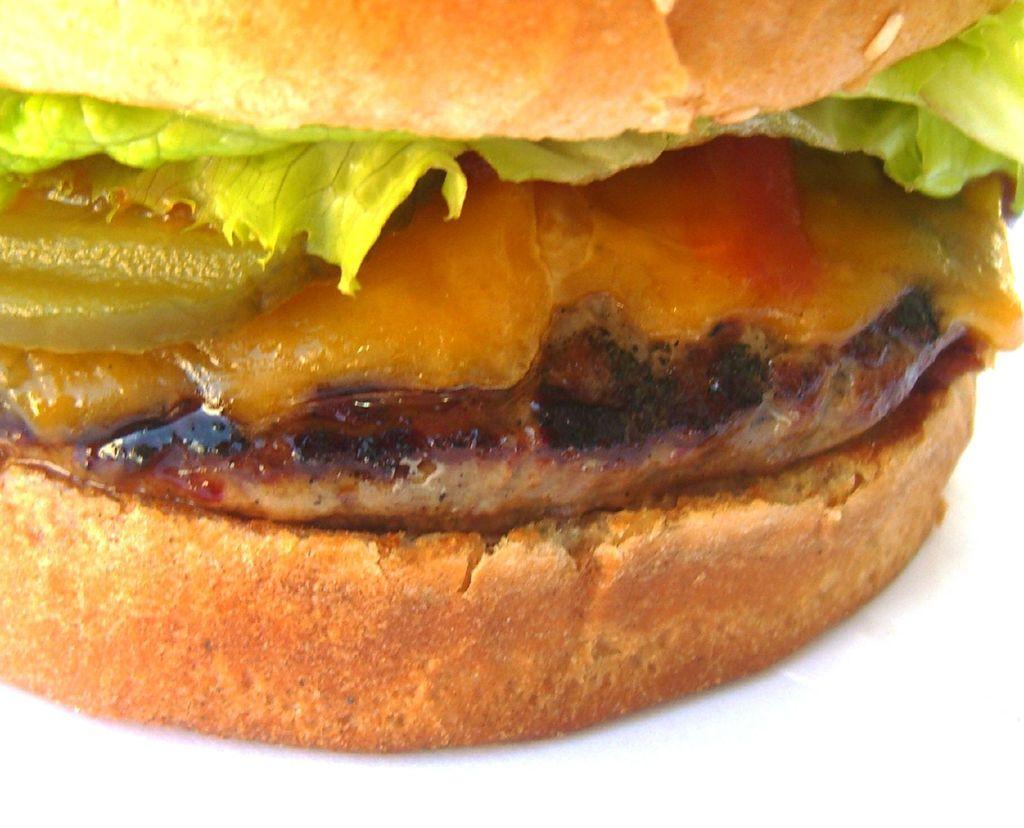Could you give a brief overview of what you see in this image? In this image there is a burger with lettuce, sauce and meat. 